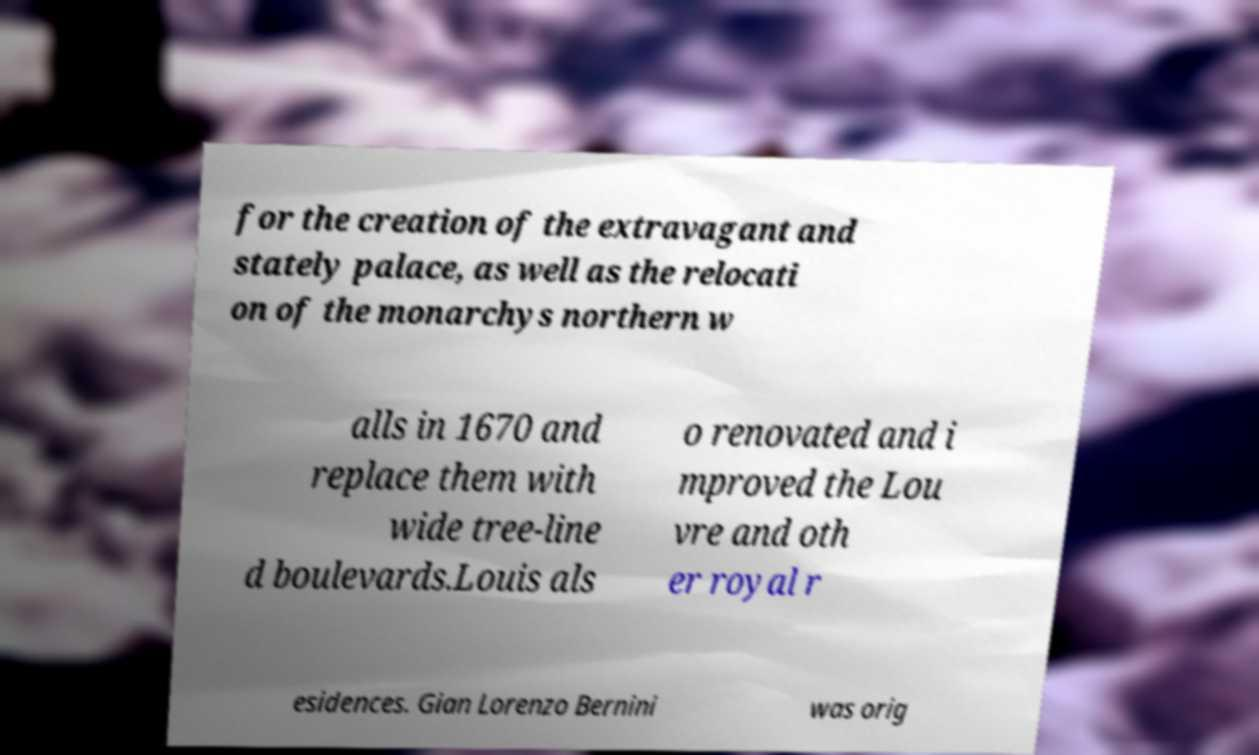Can you accurately transcribe the text from the provided image for me? for the creation of the extravagant and stately palace, as well as the relocati on of the monarchys northern w alls in 1670 and replace them with wide tree-line d boulevards.Louis als o renovated and i mproved the Lou vre and oth er royal r esidences. Gian Lorenzo Bernini was orig 